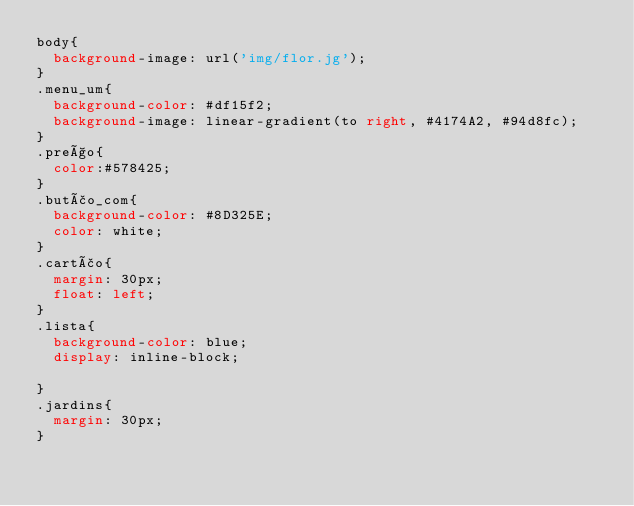Convert code to text. <code><loc_0><loc_0><loc_500><loc_500><_CSS_>body{
	background-image: url('img/flor.jg');	
}
.menu_um{
	background-color: #df15f2;
	background-image: linear-gradient(to right, #4174A2, #94d8fc);
}
.preço{
	color:#578425;
}
.butão_com{
	background-color: #8D325E;
	color: white;
}
.cartão{
	margin: 30px;
	float: left;
}
.lista{
	background-color: blue;
	display: inline-block;

}
.jardins{
	margin: 30px;
}

</code> 